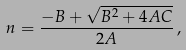<formula> <loc_0><loc_0><loc_500><loc_500>n = \frac { - B + \sqrt { B ^ { 2 } + 4 A C } } { 2 A } \, ,</formula> 